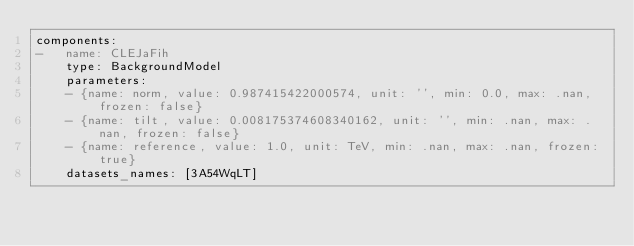<code> <loc_0><loc_0><loc_500><loc_500><_YAML_>components:
-   name: CLEJaFih
    type: BackgroundModel
    parameters:
    - {name: norm, value: 0.987415422000574, unit: '', min: 0.0, max: .nan, frozen: false}
    - {name: tilt, value: 0.008175374608340162, unit: '', min: .nan, max: .nan, frozen: false}
    - {name: reference, value: 1.0, unit: TeV, min: .nan, max: .nan, frozen: true}
    datasets_names: [3A54WqLT]
</code> 